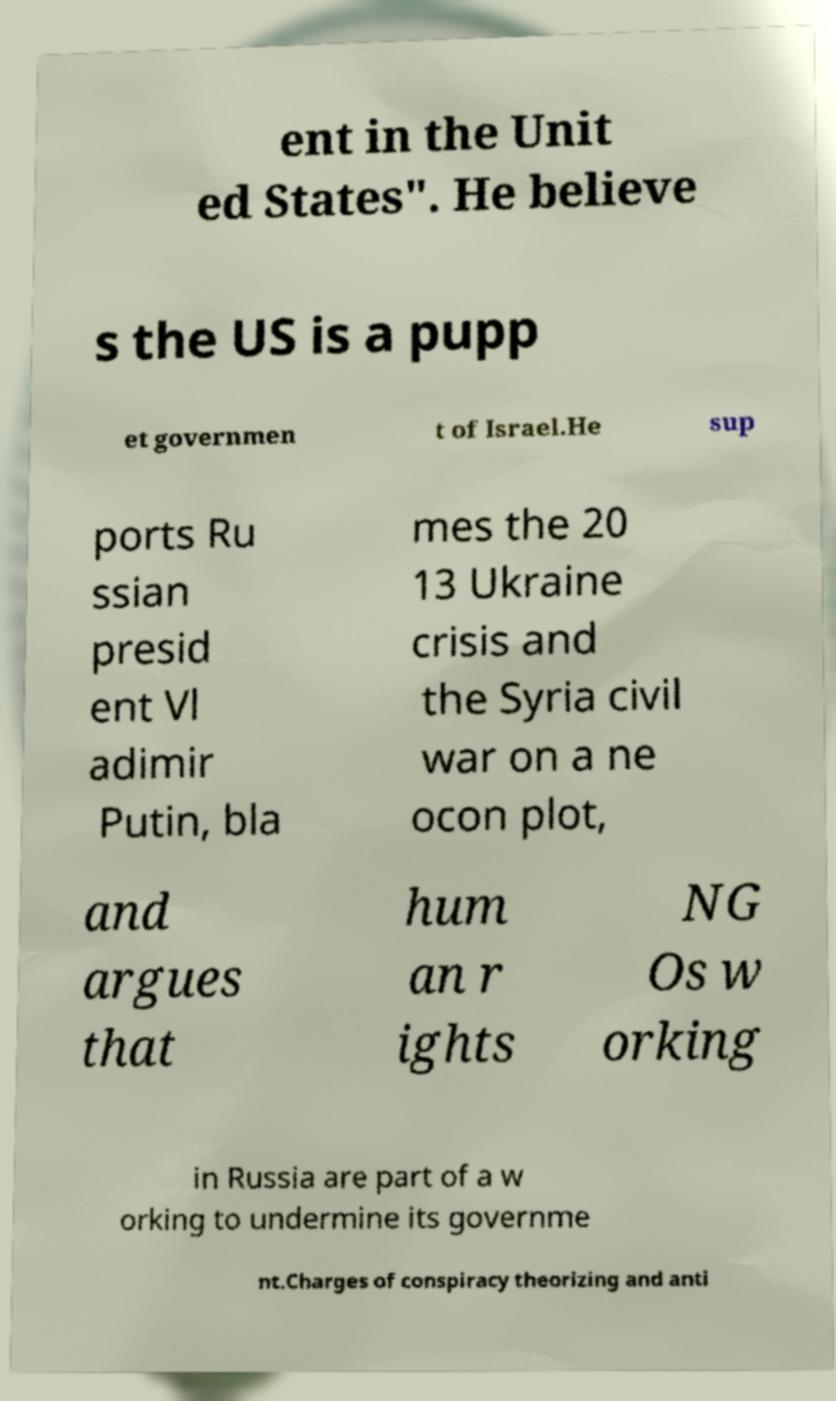For documentation purposes, I need the text within this image transcribed. Could you provide that? ent in the Unit ed States". He believe s the US is a pupp et governmen t of Israel.He sup ports Ru ssian presid ent Vl adimir Putin, bla mes the 20 13 Ukraine crisis and the Syria civil war on a ne ocon plot, and argues that hum an r ights NG Os w orking in Russia are part of a w orking to undermine its governme nt.Charges of conspiracy theorizing and anti 